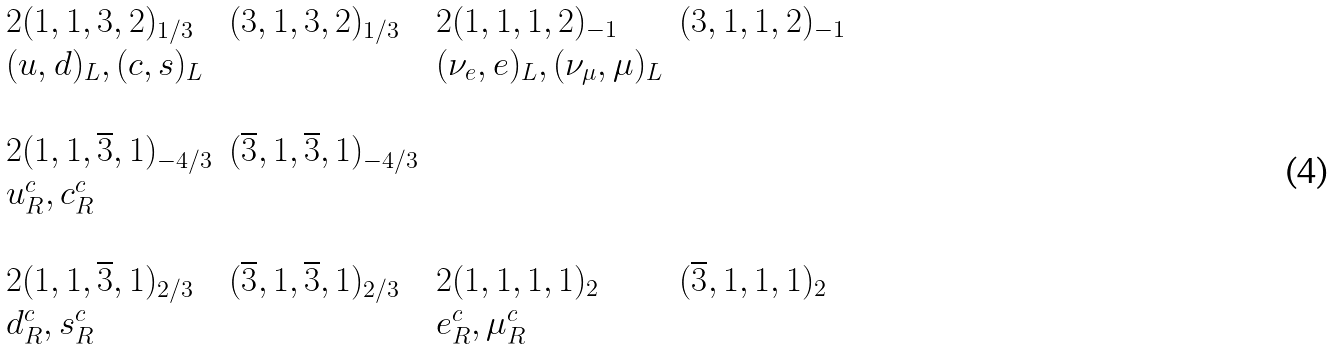<formula> <loc_0><loc_0><loc_500><loc_500>\begin{array} { l l l l } 2 ( { 1 } , { 1 } , { 3 } , { 2 } ) _ { 1 / 3 } & ( { 3 } , { 1 } , { 3 } , { 2 } ) _ { 1 / 3 } & 2 ( { 1 } , { 1 } , { 1 } , { 2 } ) _ { - 1 } & ( { 3 } , { 1 } , { 1 } , { 2 } ) _ { - 1 } \\ ( u , d ) _ { L } , ( c , s ) _ { L } & & ( \nu _ { e } , e ) _ { L } , ( \nu _ { \mu } , \mu ) _ { L } & \\ \\ 2 ( { 1 } , { 1 } , { \overline { 3 } } , { 1 } ) _ { - 4 / 3 } & ( { \overline { 3 } } , { 1 } , { \overline { 3 } } , { 1 } ) _ { - 4 / 3 } & \\ u _ { R } ^ { c } , c _ { R } ^ { c } & & & \\ \\ 2 ( { 1 } , { 1 } , { \overline { 3 } } , { 1 } ) _ { 2 / 3 } & ( { \overline { 3 } } , { 1 } , { \overline { 3 } } , { 1 } ) _ { 2 / 3 } & 2 ( { 1 } , { 1 } , { 1 } , { 1 } ) _ { 2 } & ( { \overline { 3 } } , { 1 } , { 1 } , { 1 } ) _ { 2 } \\ d _ { R } ^ { c } , s _ { R } ^ { c } & & e _ { R } ^ { c } , \mu _ { R } ^ { c } & \end{array}</formula> 